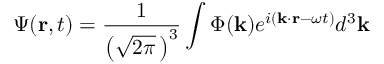<formula> <loc_0><loc_0><loc_500><loc_500>\Psi ( r , t ) = { \frac { 1 } { \left ( { \sqrt { 2 \pi } } \, \right ) ^ { 3 } } } \int \Phi ( k ) e ^ { i ( k \cdot r - \omega t ) } d ^ { 3 } k \,</formula> 